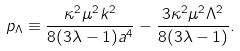<formula> <loc_0><loc_0><loc_500><loc_500>p _ { \Lambda } \equiv \frac { \kappa ^ { 2 } \mu ^ { 2 } k ^ { 2 } } { 8 ( 3 \lambda - 1 ) a ^ { 4 } } - \frac { 3 \kappa ^ { 2 } \mu ^ { 2 } \Lambda ^ { 2 } } { 8 ( 3 \lambda - 1 ) } .</formula> 